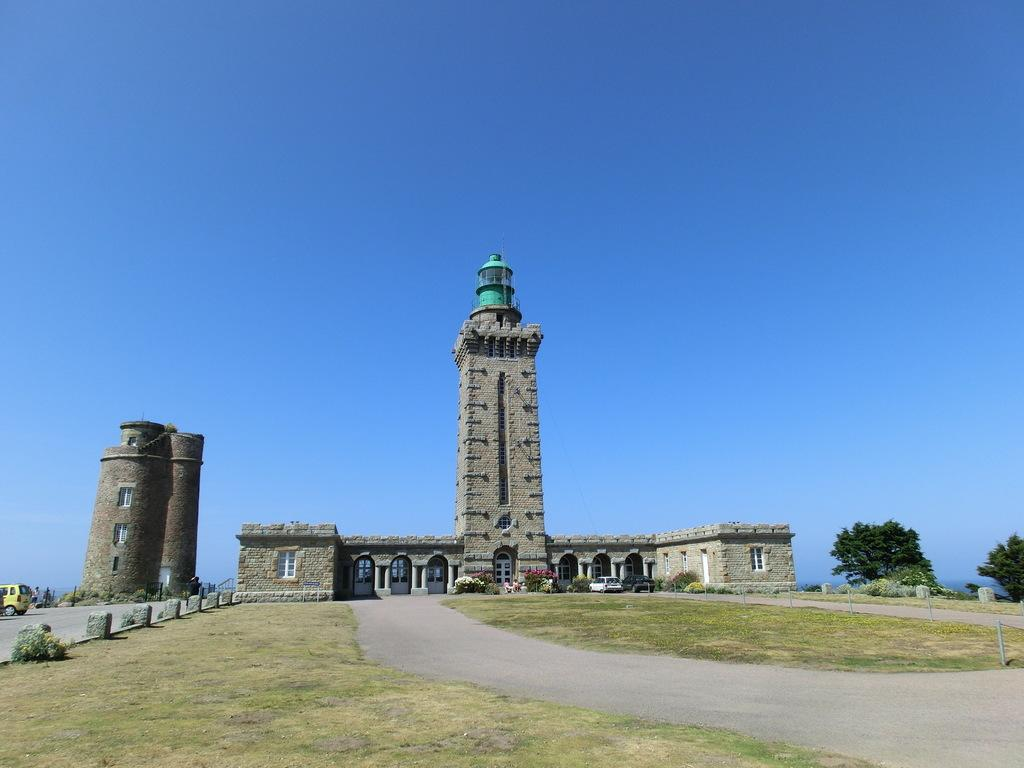What type of vegetation can be seen in the image? There is grass in the image. What type of man-made structure is present in the image? There are buildings in the image. What type of transportation is visible in the image? There is a vehicle in the image. What architectural feature can be seen in the image? There are windows in the image. What type of natural feature is present in the image? There are trees in the image. What part of the natural environment is visible in the image? The sky is visible in the image. What type of company is depicted in the image? There is no company depicted in the image; it features grass, a vehicle, buildings, windows, trees, and the sky. Can you tell me how many rats are visible in the image? There are no rats present in the image. 